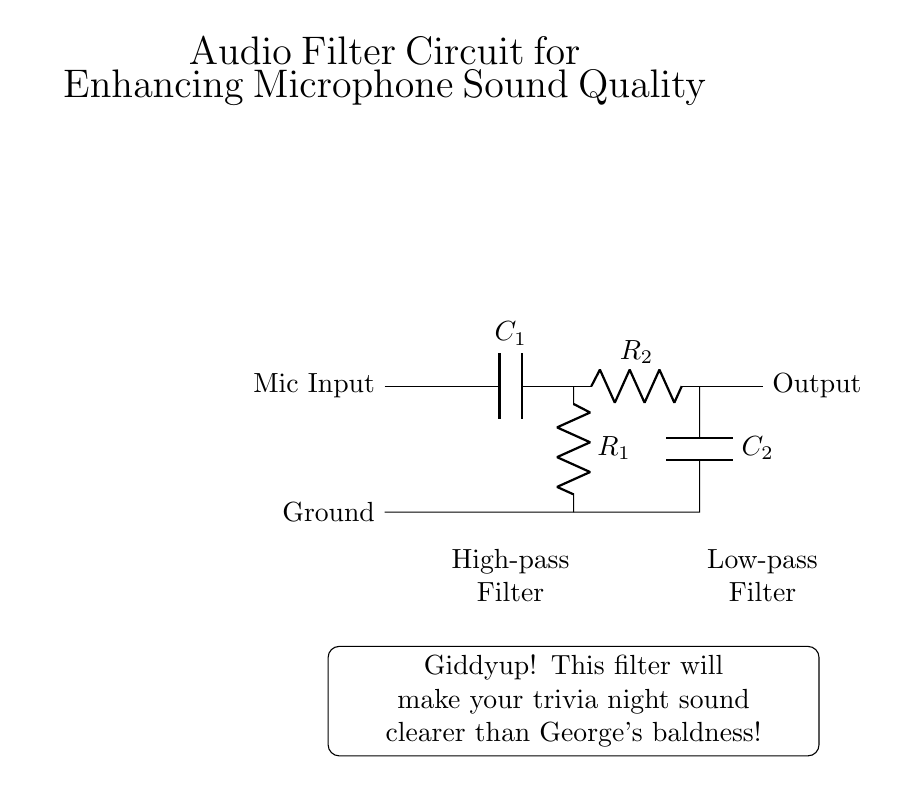What component is labeled C1? C1 is the capacitor in the high-pass filter section of the circuit.
Answer: Capacitor What does the output of the circuit connect to? The output connects to the system that processes the microphone audio signal.
Answer: Output How many resistors are present in this circuit? There are two resistors labeled R1 and R2 in this circuit.
Answer: Two What type of filter is represented by the section including R2 and C2? The section with R2 and C2 is a low-pass filter, which allows low-frequency signals to pass while attenuating high-frequency signals.
Answer: Low-pass filter Which component is placed between the mic input and the ground? The capacitor C1 is connected in series with the resistor R1, and they both lead to the ground.
Answer: Capacitor How does the configuration of R1 and C1 affect audio signals? The configuration forms a high-pass filter that removes low-frequency sounds, thus enhancing the clarity of higher-frequency audio signals such as voices.
Answer: High-pass Which sequence of components forms the high-pass filter? The high-pass filter is formed by the series connection of capacitor C1 followed by resistor R1.
Answer: C1 and R1 